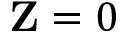<formula> <loc_0><loc_0><loc_500><loc_500>Z = 0</formula> 